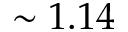Convert formula to latex. <formula><loc_0><loc_0><loc_500><loc_500>\sim 1 . 1 4</formula> 